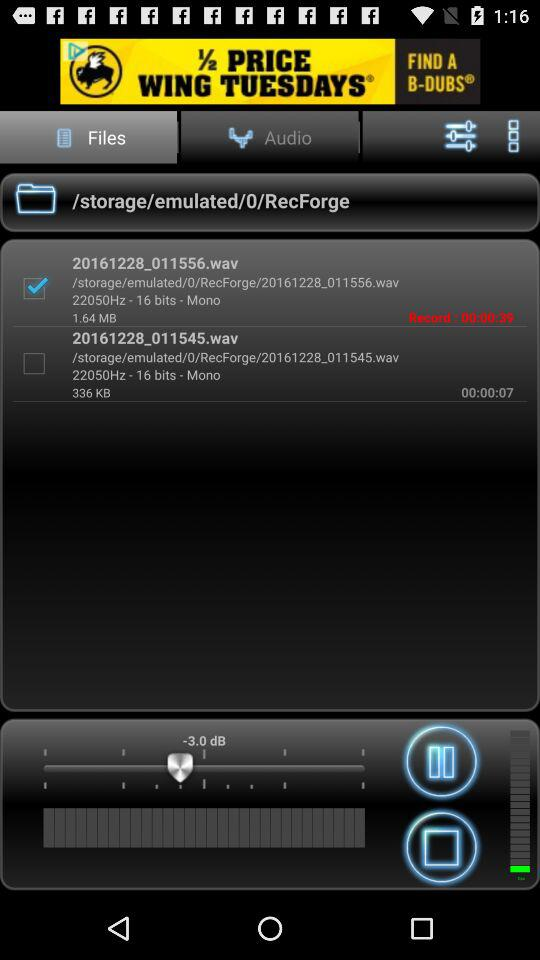How many more seconds is the longer recording than the shorter recording?
Answer the question using a single word or phrase. 32 